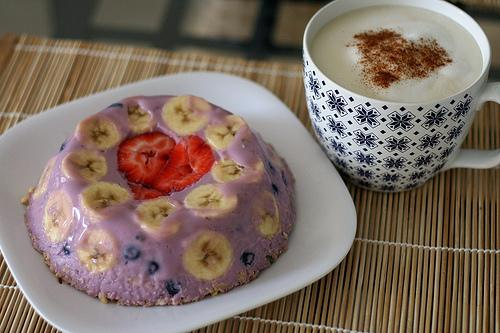Describe the sentiment or atmosphere that the image portrays, considering the objects and their arrangement. The image depicts a delightful and appetizing breakfast scene, creating a cozy and inviting atmosphere with a delicious dessert and a warm beverage. What type of cup is on the table and mention the design on it? A white coffee cup with a blue design and black and white details is on the table. Identify the type of dessert on the white square plate and describe the fruits it contains. The dessert is a purple flan filled with strawberries, sliced bananas, and blueberries. Determine the type of placemat on the table and describe its color and material. The placemat is a brown wicker placemat sewn with white thread, made of straw. Quantify the number of objects in the picture including the dessert, cup, plate, and placemat. There are four objects in the picture: dessert, cup, plate, and placemat. Provide a brief description of the placement of the objects in the image. A white square plate with dessert and a white cup are sitting on a brown and white straw placemat on a bamboo table. Explain the overall scene of the image by specifying the objects and their arrangement. Breakfast is served on a bamboo table with a purple flan on a white plate, accompanied by a white cup with a blue design, all placed on a brown and white straw placemat. Analyze the interaction between the objects in the image. Which objects have a direct connection with each other? The white square plate has a purple flan on it, and both the plate and the white cup with a blue design are placed on the straw placemat. Comment on the state of the dessert on the plate and whether it has any toppings. The dessert is a purple flan with a generous topping of strawberries, sliced bananas, and blueberries. List three types of fruits in the dessert. Strawberries, sliced bananas, and blueberries. 